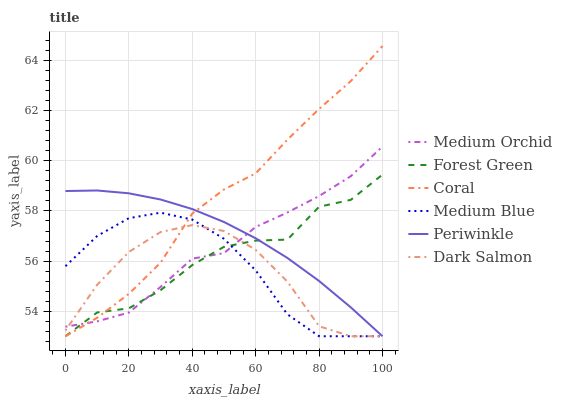Does Dark Salmon have the minimum area under the curve?
Answer yes or no. Yes. Does Coral have the maximum area under the curve?
Answer yes or no. Yes. Does Medium Orchid have the minimum area under the curve?
Answer yes or no. No. Does Medium Orchid have the maximum area under the curve?
Answer yes or no. No. Is Periwinkle the smoothest?
Answer yes or no. Yes. Is Forest Green the roughest?
Answer yes or no. Yes. Is Medium Orchid the smoothest?
Answer yes or no. No. Is Medium Orchid the roughest?
Answer yes or no. No. Does Coral have the lowest value?
Answer yes or no. Yes. Does Medium Orchid have the lowest value?
Answer yes or no. No. Does Coral have the highest value?
Answer yes or no. Yes. Does Medium Orchid have the highest value?
Answer yes or no. No. Does Medium Orchid intersect Coral?
Answer yes or no. Yes. Is Medium Orchid less than Coral?
Answer yes or no. No. Is Medium Orchid greater than Coral?
Answer yes or no. No. 